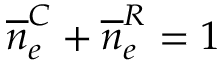<formula> <loc_0><loc_0><loc_500><loc_500>\overline { n } _ { e } ^ { C } + \overline { n } _ { e } ^ { R } = 1</formula> 